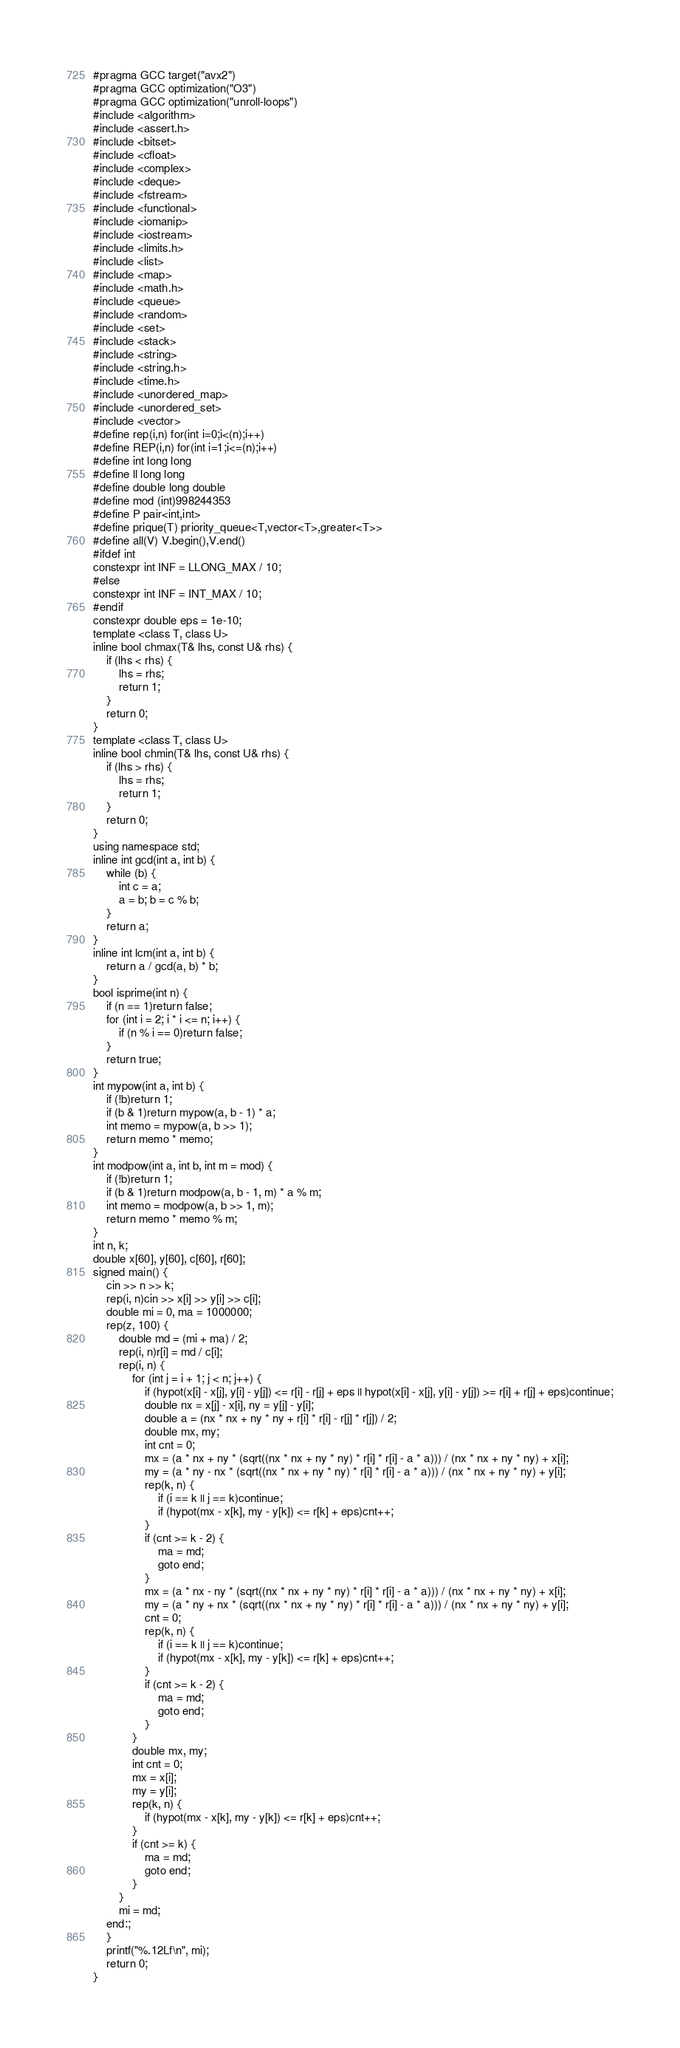Convert code to text. <code><loc_0><loc_0><loc_500><loc_500><_C++_>#pragma GCC target("avx2")
#pragma GCC optimization("O3")
#pragma GCC optimization("unroll-loops")
#include <algorithm>
#include <assert.h>
#include <bitset>
#include <cfloat>
#include <complex>
#include <deque>
#include <fstream>
#include <functional>
#include <iomanip>
#include <iostream>
#include <limits.h>
#include <list>
#include <map>
#include <math.h>
#include <queue>
#include <random>
#include <set>
#include <stack>
#include <string>
#include <string.h>
#include <time.h>
#include <unordered_map>
#include <unordered_set>
#include <vector>
#define rep(i,n) for(int i=0;i<(n);i++)
#define REP(i,n) for(int i=1;i<=(n);i++)
#define int long long
#define ll long long
#define double long double
#define mod (int)998244353
#define P pair<int,int>
#define prique(T) priority_queue<T,vector<T>,greater<T>>
#define all(V) V.begin(),V.end()
#ifdef int
constexpr int INF = LLONG_MAX / 10;
#else
constexpr int INF = INT_MAX / 10;
#endif
constexpr double eps = 1e-10;
template <class T, class U>
inline bool chmax(T& lhs, const U& rhs) {
	if (lhs < rhs) {
		lhs = rhs;
		return 1;
	}
	return 0;
}
template <class T, class U>
inline bool chmin(T& lhs, const U& rhs) {
	if (lhs > rhs) {
		lhs = rhs;
		return 1;
	}
	return 0;
}
using namespace std;
inline int gcd(int a, int b) {
	while (b) {
		int c = a;
		a = b; b = c % b;
	}
	return a;
}
inline int lcm(int a, int b) {
	return a / gcd(a, b) * b;
}
bool isprime(int n) {
	if (n == 1)return false;
	for (int i = 2; i * i <= n; i++) {
		if (n % i == 0)return false;
	}
	return true;
}
int mypow(int a, int b) {
	if (!b)return 1;
	if (b & 1)return mypow(a, b - 1) * a;
	int memo = mypow(a, b >> 1);
	return memo * memo;
}
int modpow(int a, int b, int m = mod) {
	if (!b)return 1;
	if (b & 1)return modpow(a, b - 1, m) * a % m;
	int memo = modpow(a, b >> 1, m);
	return memo * memo % m;
}
int n, k;
double x[60], y[60], c[60], r[60];
signed main() {
	cin >> n >> k;
	rep(i, n)cin >> x[i] >> y[i] >> c[i];
	double mi = 0, ma = 1000000;
	rep(z, 100) {
		double md = (mi + ma) / 2;
		rep(i, n)r[i] = md / c[i];
		rep(i, n) {
			for (int j = i + 1; j < n; j++) {
				if (hypot(x[i] - x[j], y[i] - y[j]) <= r[i] - r[j] + eps || hypot(x[i] - x[j], y[i] - y[j]) >= r[i] + r[j] + eps)continue;
				double nx = x[j] - x[i], ny = y[j] - y[i];
				double a = (nx * nx + ny * ny + r[i] * r[i] - r[j] * r[j]) / 2;
				double mx, my;
				int cnt = 0;
				mx = (a * nx + ny * (sqrt((nx * nx + ny * ny) * r[i] * r[i] - a * a))) / (nx * nx + ny * ny) + x[i];
				my = (a * ny - nx * (sqrt((nx * nx + ny * ny) * r[i] * r[i] - a * a))) / (nx * nx + ny * ny) + y[i];
				rep(k, n) {
					if (i == k || j == k)continue;
					if (hypot(mx - x[k], my - y[k]) <= r[k] + eps)cnt++;
				}
				if (cnt >= k - 2) {
					ma = md;
					goto end;
				}
				mx = (a * nx - ny * (sqrt((nx * nx + ny * ny) * r[i] * r[i] - a * a))) / (nx * nx + ny * ny) + x[i];
				my = (a * ny + nx * (sqrt((nx * nx + ny * ny) * r[i] * r[i] - a * a))) / (nx * nx + ny * ny) + y[i];
				cnt = 0;
				rep(k, n) {
					if (i == k || j == k)continue;
					if (hypot(mx - x[k], my - y[k]) <= r[k] + eps)cnt++;
				}
				if (cnt >= k - 2) {
					ma = md;
					goto end;
				}
			}
			double mx, my;
			int cnt = 0;
			mx = x[i];
			my = y[i];
			rep(k, n) {
				if (hypot(mx - x[k], my - y[k]) <= r[k] + eps)cnt++;
			}
			if (cnt >= k) {
				ma = md;
				goto end;
			}
		}
		mi = md;
	end:;
	}
	printf("%.12Lf\n", mi);
	return 0;
}</code> 